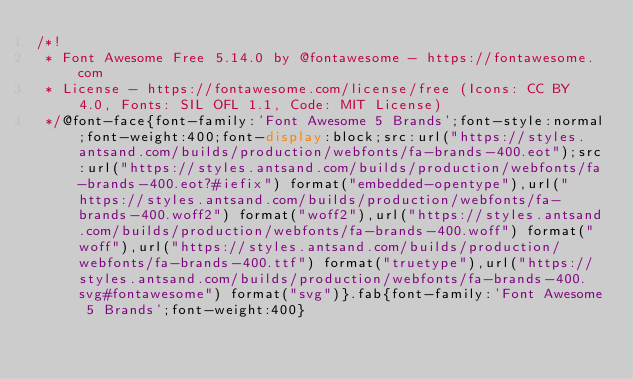Convert code to text. <code><loc_0><loc_0><loc_500><loc_500><_CSS_>/*!
 * Font Awesome Free 5.14.0 by @fontawesome - https://fontawesome.com
 * License - https://fontawesome.com/license/free (Icons: CC BY 4.0, Fonts: SIL OFL 1.1, Code: MIT License)
 */@font-face{font-family:'Font Awesome 5 Brands';font-style:normal;font-weight:400;font-display:block;src:url("https://styles.antsand.com/builds/production/webfonts/fa-brands-400.eot");src:url("https://styles.antsand.com/builds/production/webfonts/fa-brands-400.eot?#iefix") format("embedded-opentype"),url("https://styles.antsand.com/builds/production/webfonts/fa-brands-400.woff2") format("woff2"),url("https://styles.antsand.com/builds/production/webfonts/fa-brands-400.woff") format("woff"),url("https://styles.antsand.com/builds/production/webfonts/fa-brands-400.ttf") format("truetype"),url("https://styles.antsand.com/builds/production/webfonts/fa-brands-400.svg#fontawesome") format("svg")}.fab{font-family:'Font Awesome 5 Brands';font-weight:400}
</code> 